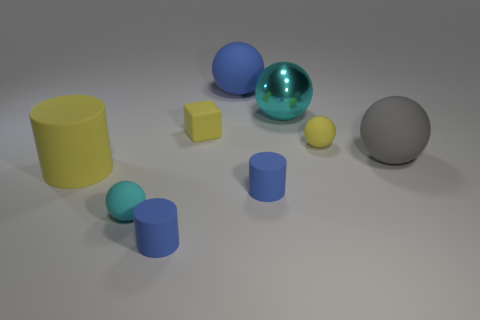Subtract all yellow rubber cylinders. How many cylinders are left? 2 Add 1 blocks. How many objects exist? 10 Subtract all gray balls. How many balls are left? 4 Subtract 4 spheres. How many spheres are left? 1 Subtract all blue blocks. How many green spheres are left? 0 Add 4 large things. How many large things exist? 8 Subtract 0 green balls. How many objects are left? 9 Subtract all cylinders. How many objects are left? 6 Subtract all cyan blocks. Subtract all brown balls. How many blocks are left? 1 Subtract all yellow cylinders. Subtract all gray matte objects. How many objects are left? 7 